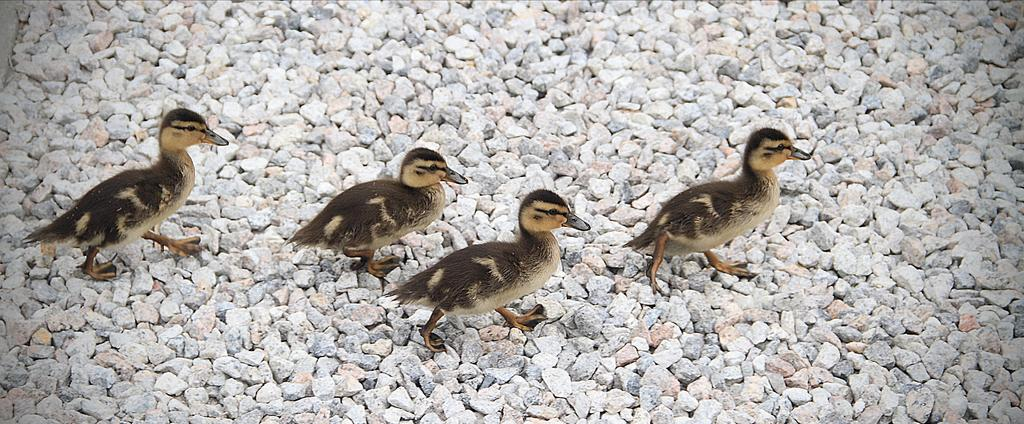How many birds can be seen in the image? There are 4 birds in the image. What colors are the birds in the image? The birds are brown and cream in color. What else can be seen in the image besides the birds? There are stones visible in the image. Where is the faucet located in the image? There is no faucet present in the image. How many chairs can be seen in the image? There are no chairs present in the image. 